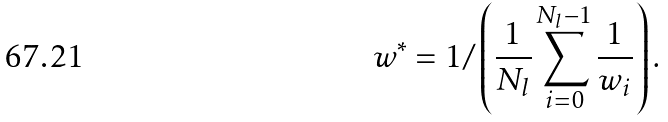<formula> <loc_0><loc_0><loc_500><loc_500>w ^ { * } = 1 / \left ( \frac { 1 } { N _ { l } } \sum _ { i = 0 } ^ { N _ { l } - 1 } \frac { 1 } { w _ { i } } \right ) .</formula> 